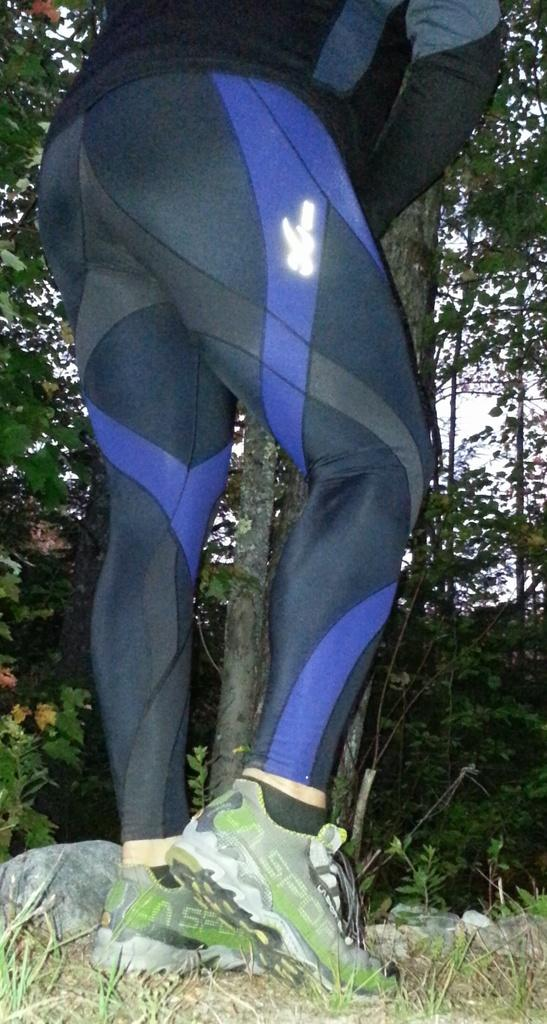Who or what is present in the image? There is a person in the image. What can be seen in the distance behind the person? There are trees in the background of the image. What type of natural features are visible in the image? There are rocks visible in the image. What type of roof is visible in the image? There is no roof present in the image. 